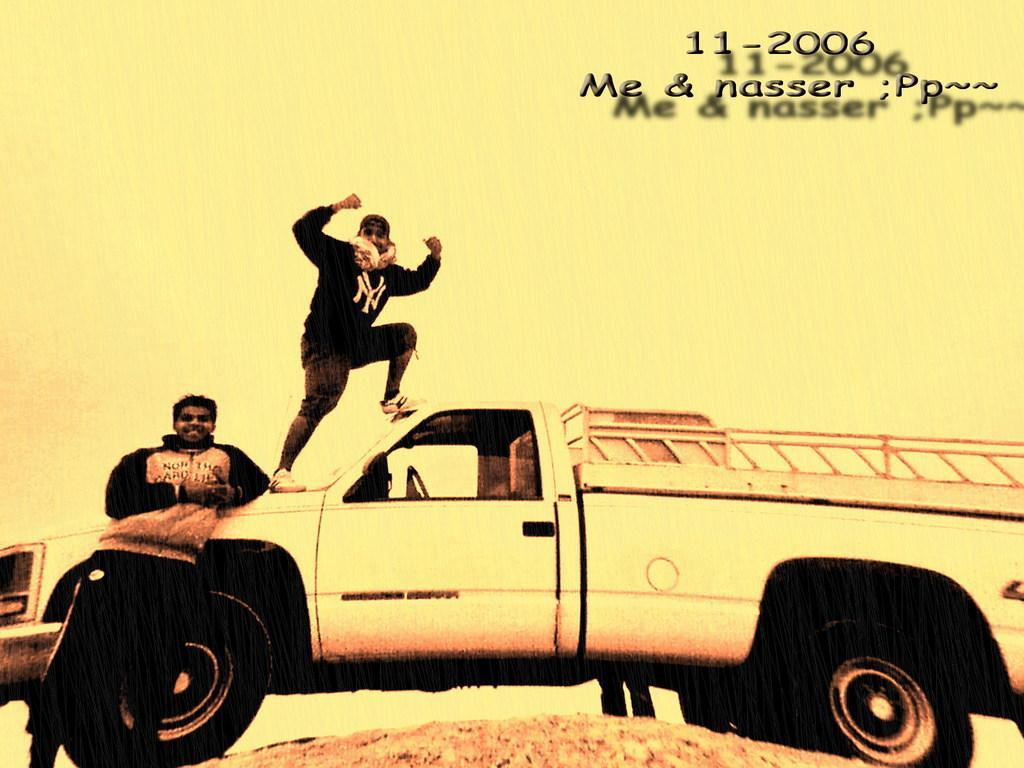How would you summarize this image in a sentence or two? Here in this picture we can see a truck present on the ground and on the left side we can see a person standing on the ground and smiling and we can also see another person standing on the truck and smiling. 